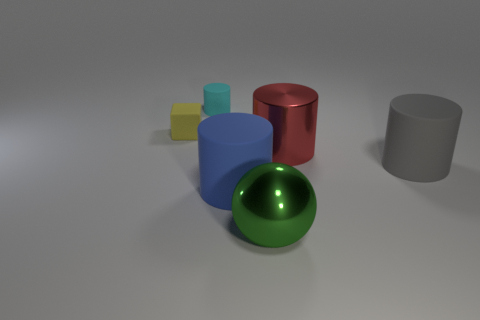How many other objects are there of the same shape as the yellow object?
Provide a succinct answer. 0. Do the metallic cylinder and the green shiny thing have the same size?
Your answer should be compact. Yes. Are any large green metallic balls visible?
Give a very brief answer. Yes. Are there any cyan things made of the same material as the block?
Give a very brief answer. Yes. What material is the gray thing that is the same size as the green ball?
Provide a succinct answer. Rubber. How many other gray matte objects have the same shape as the large gray rubber object?
Your answer should be compact. 0. There is a green thing that is made of the same material as the large red thing; what size is it?
Ensure brevity in your answer.  Large. The thing that is behind the gray matte cylinder and right of the sphere is made of what material?
Make the answer very short. Metal. How many gray matte cylinders are the same size as the green object?
Provide a succinct answer. 1. What material is the large red object that is the same shape as the gray thing?
Give a very brief answer. Metal. 